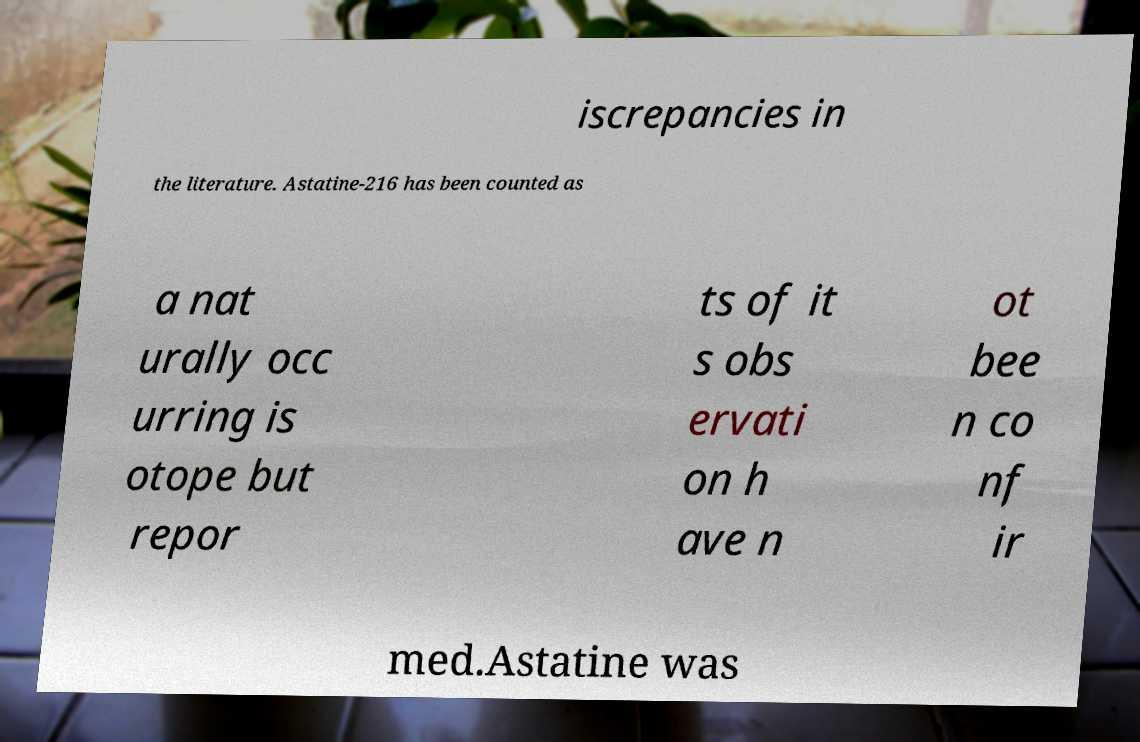Can you read and provide the text displayed in the image?This photo seems to have some interesting text. Can you extract and type it out for me? iscrepancies in the literature. Astatine-216 has been counted as a nat urally occ urring is otope but repor ts of it s obs ervati on h ave n ot bee n co nf ir med.Astatine was 